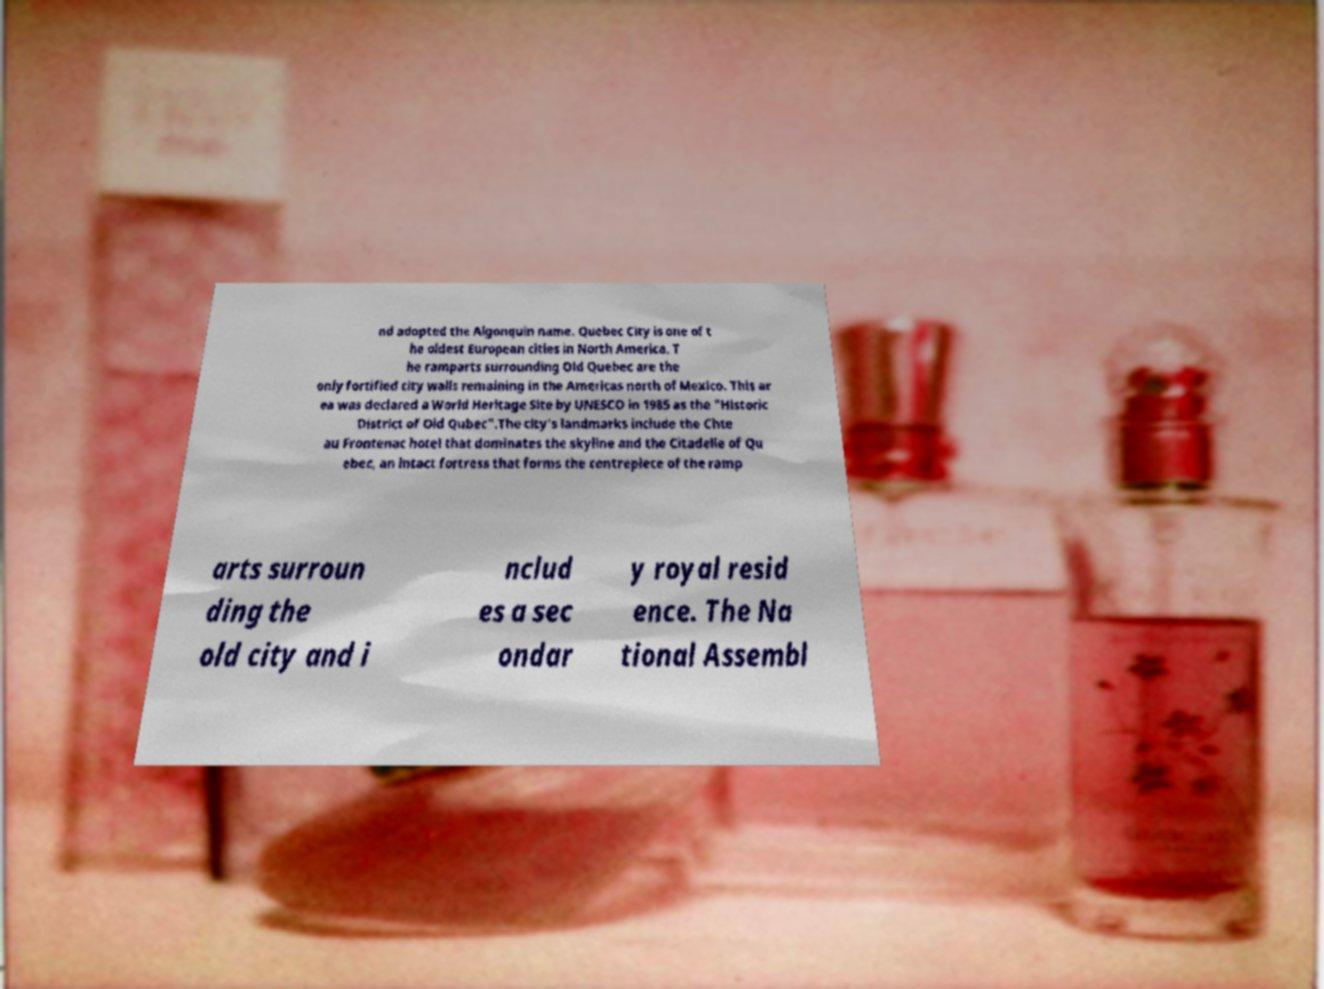Could you assist in decoding the text presented in this image and type it out clearly? nd adopted the Algonquin name. Quebec City is one of t he oldest European cities in North America. T he ramparts surrounding Old Quebec are the only fortified city walls remaining in the Americas north of Mexico. This ar ea was declared a World Heritage Site by UNESCO in 1985 as the "Historic District of Old Qubec".The city's landmarks include the Chte au Frontenac hotel that dominates the skyline and the Citadelle of Qu ebec, an intact fortress that forms the centrepiece of the ramp arts surroun ding the old city and i nclud es a sec ondar y royal resid ence. The Na tional Assembl 